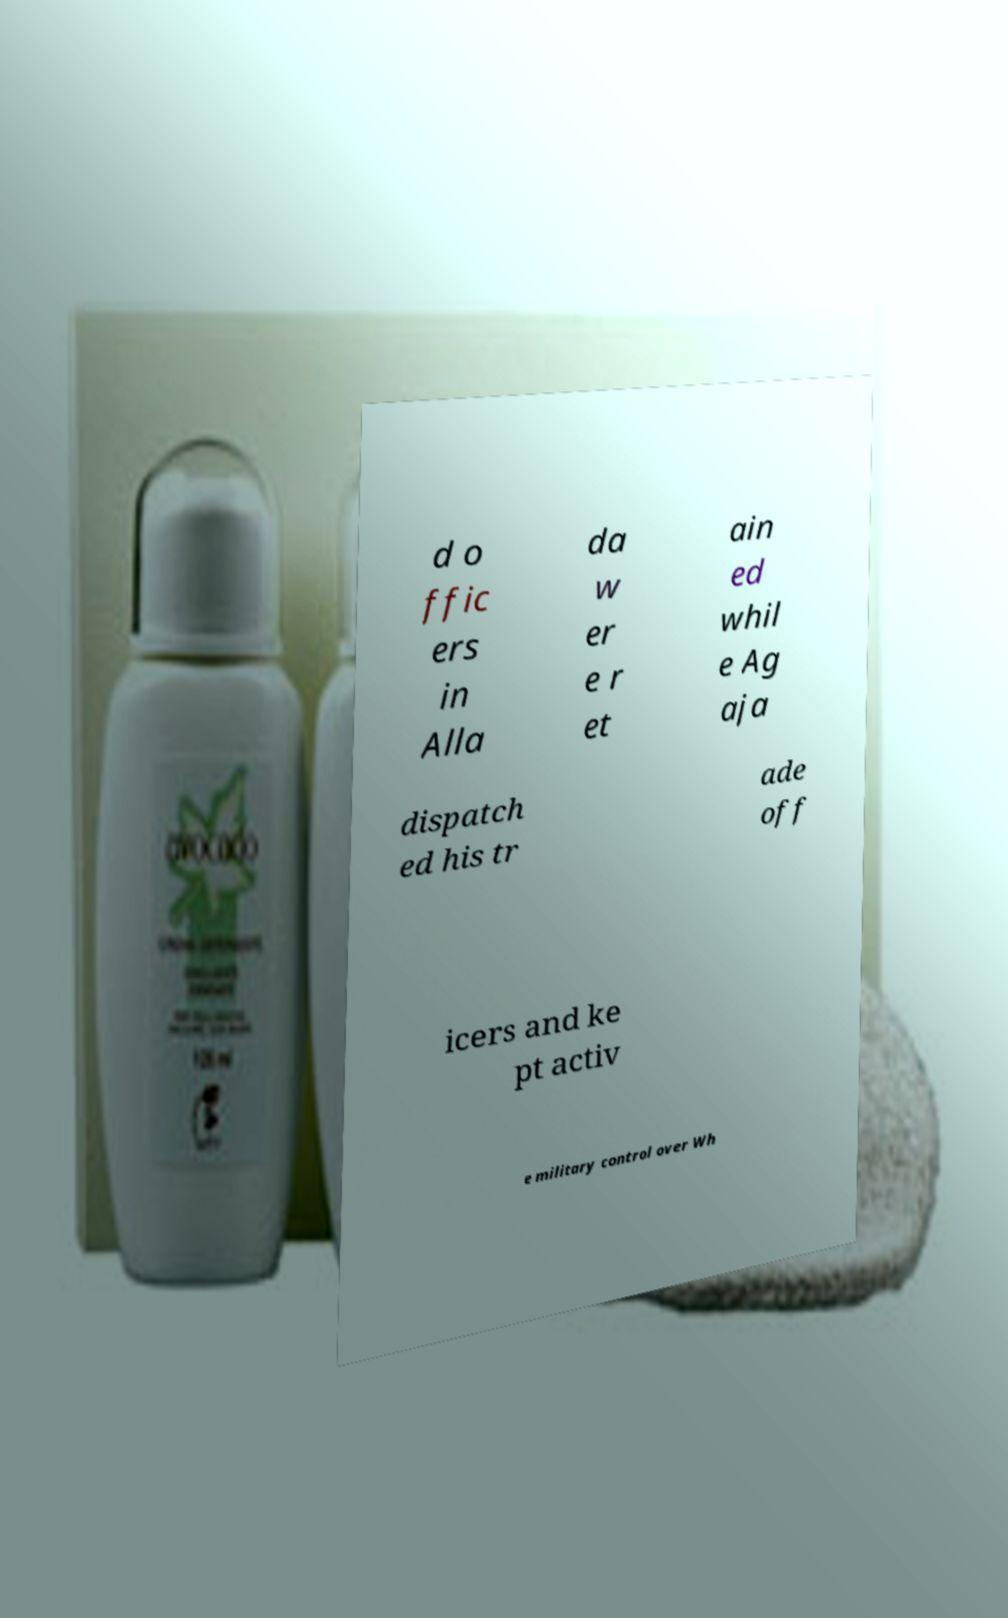Could you assist in decoding the text presented in this image and type it out clearly? d o ffic ers in Alla da w er e r et ain ed whil e Ag aja dispatch ed his tr ade off icers and ke pt activ e military control over Wh 